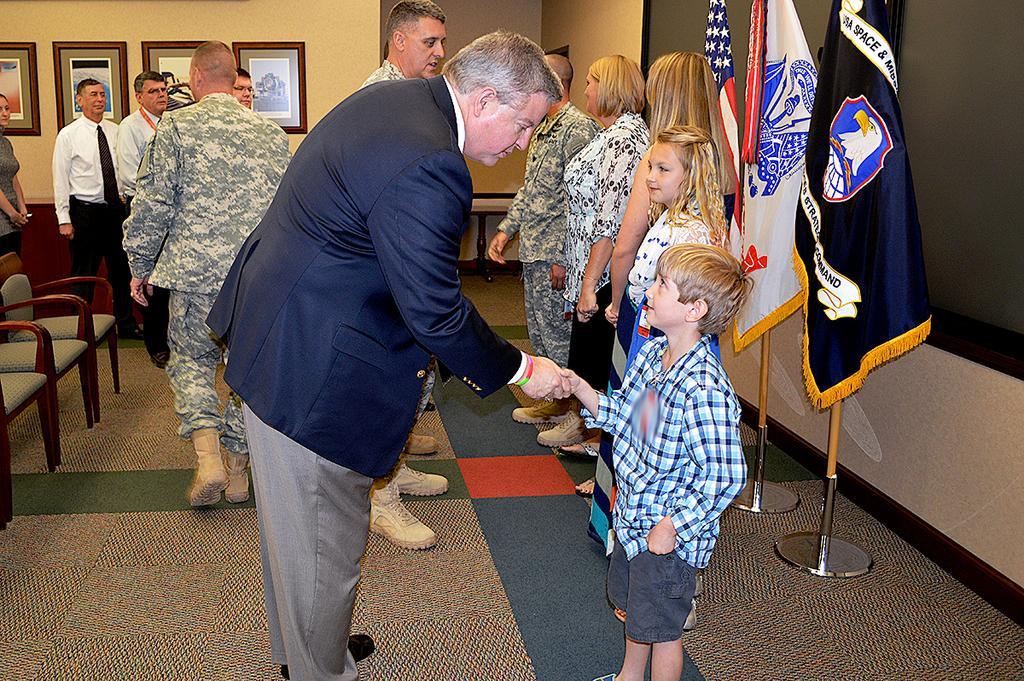Please provide a concise description of this image. In the picture we can find some people are standing and one man is holding a boy hand. In the background we can find a wall, photos and chairs and three flags near to the black board. 